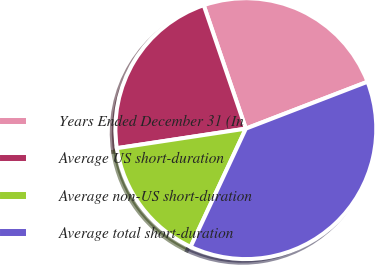<chart> <loc_0><loc_0><loc_500><loc_500><pie_chart><fcel>Years Ended December 31 (In<fcel>Average US short-duration<fcel>Average non-US short-duration<fcel>Average total short-duration<nl><fcel>24.38%<fcel>22.16%<fcel>15.65%<fcel>37.81%<nl></chart> 